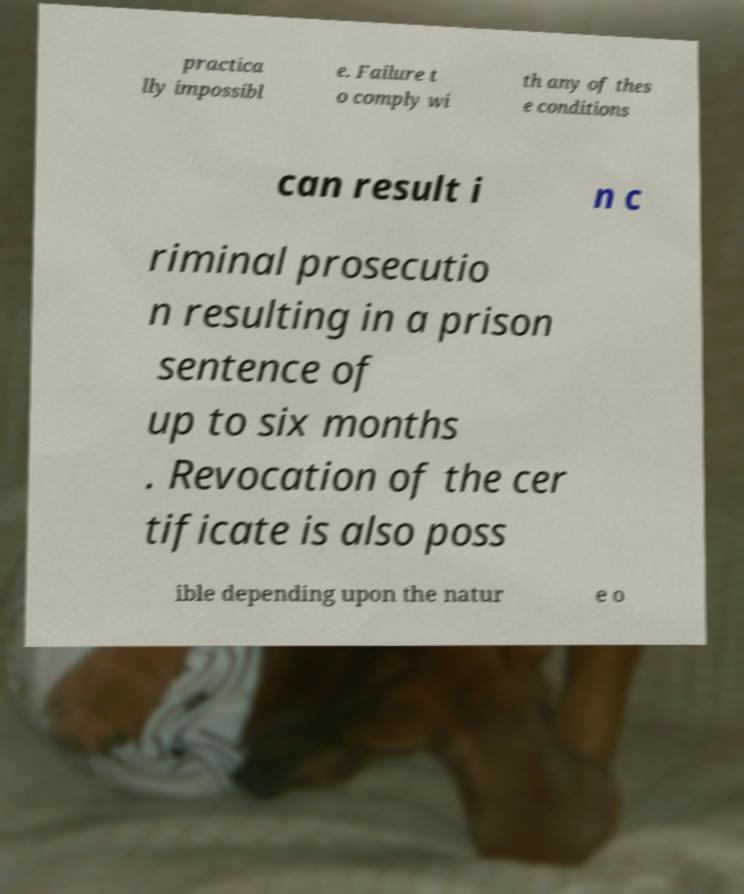Can you accurately transcribe the text from the provided image for me? practica lly impossibl e. Failure t o comply wi th any of thes e conditions can result i n c riminal prosecutio n resulting in a prison sentence of up to six months . Revocation of the cer tificate is also poss ible depending upon the natur e o 